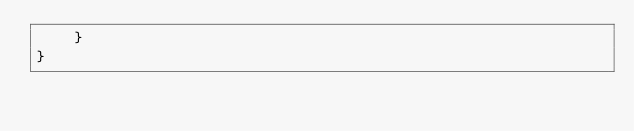Convert code to text. <code><loc_0><loc_0><loc_500><loc_500><_C#_>    }
}</code> 